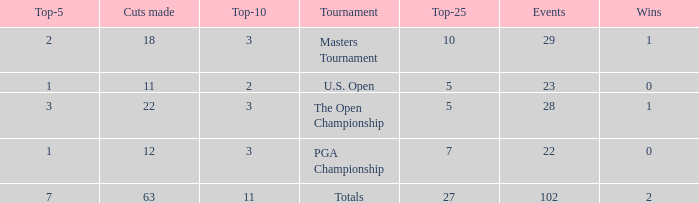How many vuts made for a player with 2 wins and under 7 top 5s? None. 